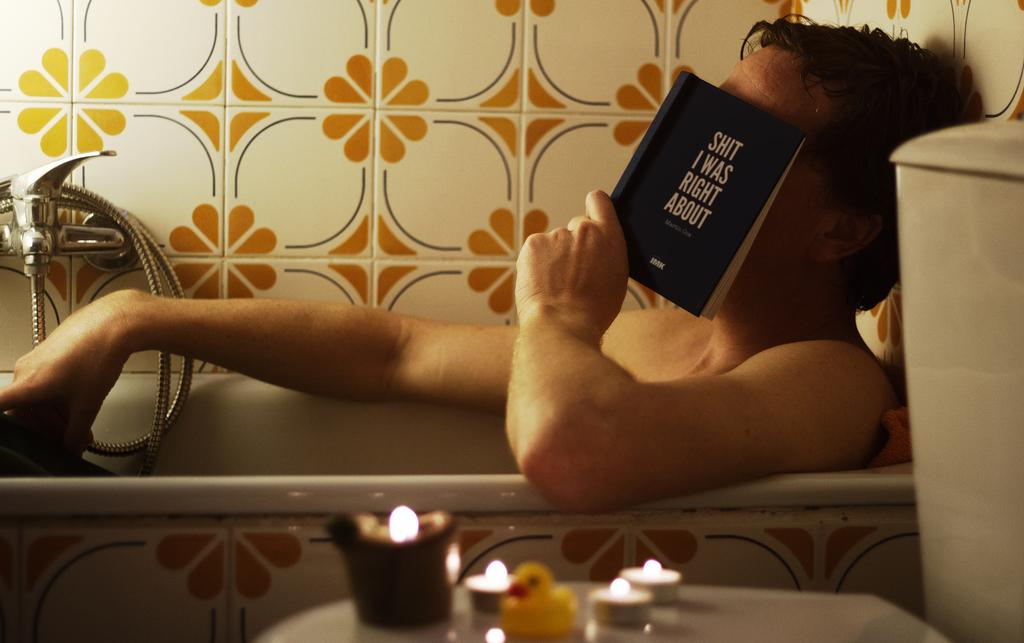Provide a one-sentence caption for the provided image. A man in the tub, covering his face with a book called Shit I was Right About. 